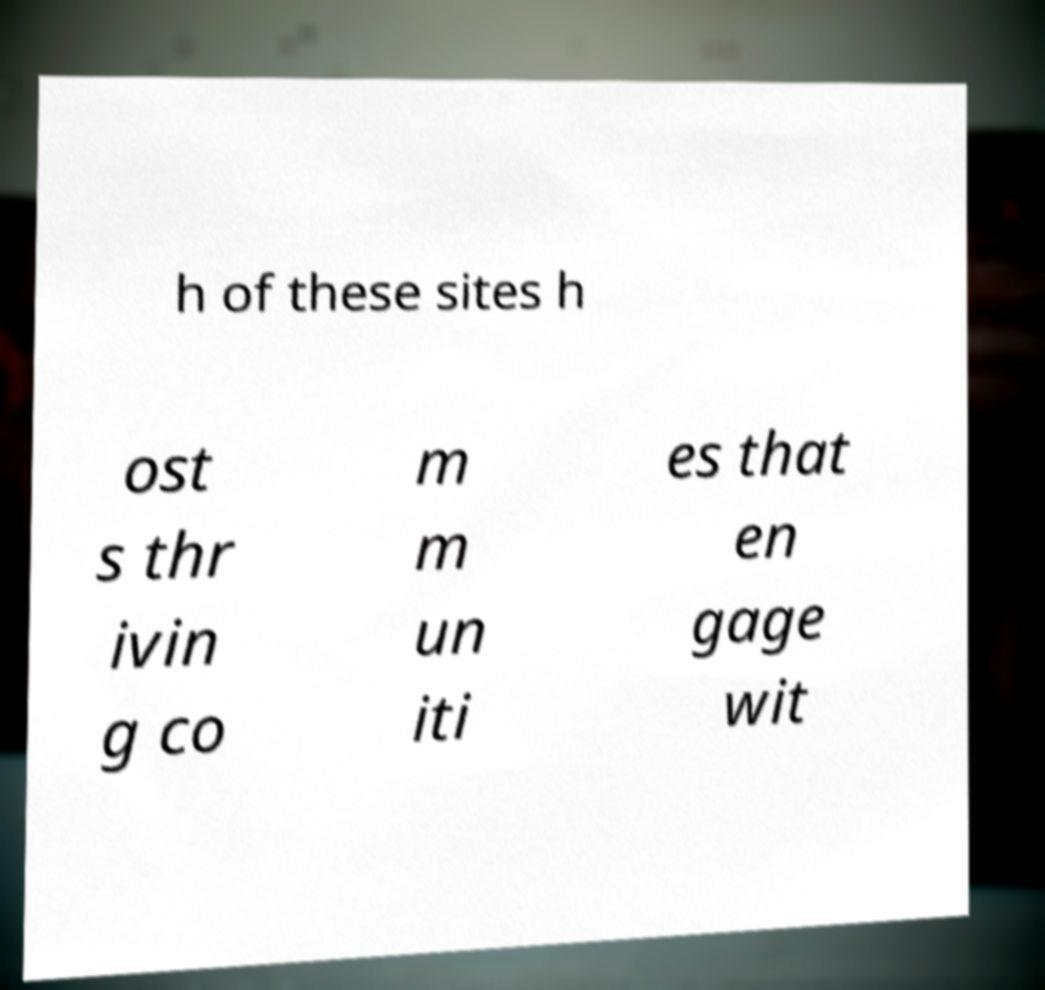For documentation purposes, I need the text within this image transcribed. Could you provide that? h of these sites h ost s thr ivin g co m m un iti es that en gage wit 